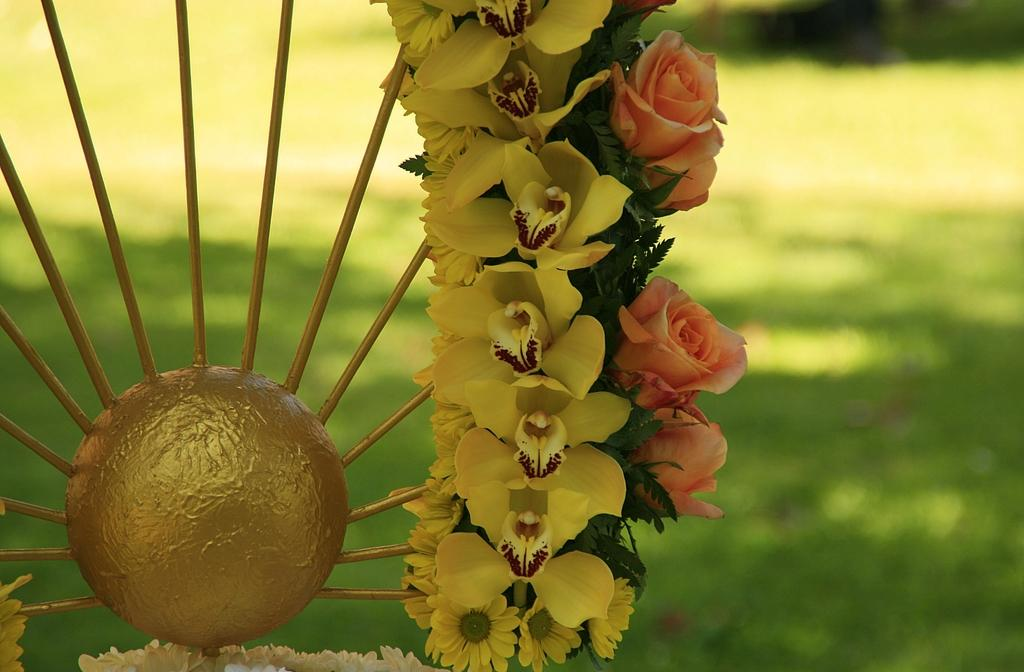What type of decorative item can be seen on the left side of the image? There is a decorative item with flowers on the left side of the image. What type of vegetation is visible at the bottom of the image? There is grass at the bottom of the image. Can you see a rifle resting on the decorative item with flowers? There is no rifle present in the image. What type of yoke can be seen supporting the decorative item with flowers? There is no yoke present in the image; the decorative item with flowers is not supported by any visible yoke. 